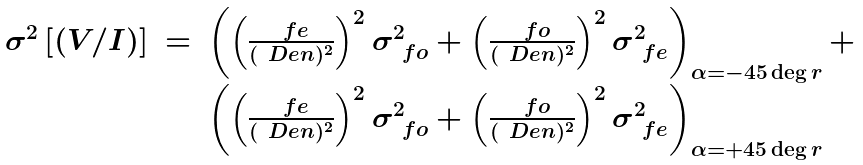<formula> <loc_0><loc_0><loc_500><loc_500>\begin{array} { r c l } \sigma ^ { 2 } \left [ ( V / I ) \right ] & = & \left ( \left ( \frac { \ f e } { ( \ D e n ) ^ { 2 } } \right ) ^ { 2 } \sigma ^ { 2 } _ { \ f o } + \left ( \frac { \ f o } { ( \ D e n ) ^ { 2 } } \right ) ^ { 2 } \sigma ^ { 2 } _ { \ f e } \right ) _ { \alpha = - 4 5 \deg r } + \\ & & \left ( \left ( \frac { \ f e } { ( \ D e n ) ^ { 2 } } \right ) ^ { 2 } \sigma ^ { 2 } _ { \ f o } + \left ( \frac { \ f o } { ( \ D e n ) ^ { 2 } } \right ) ^ { 2 } \sigma ^ { 2 } _ { \ f e } \right ) _ { \alpha = + 4 5 \deg r } \\ \end{array}</formula> 